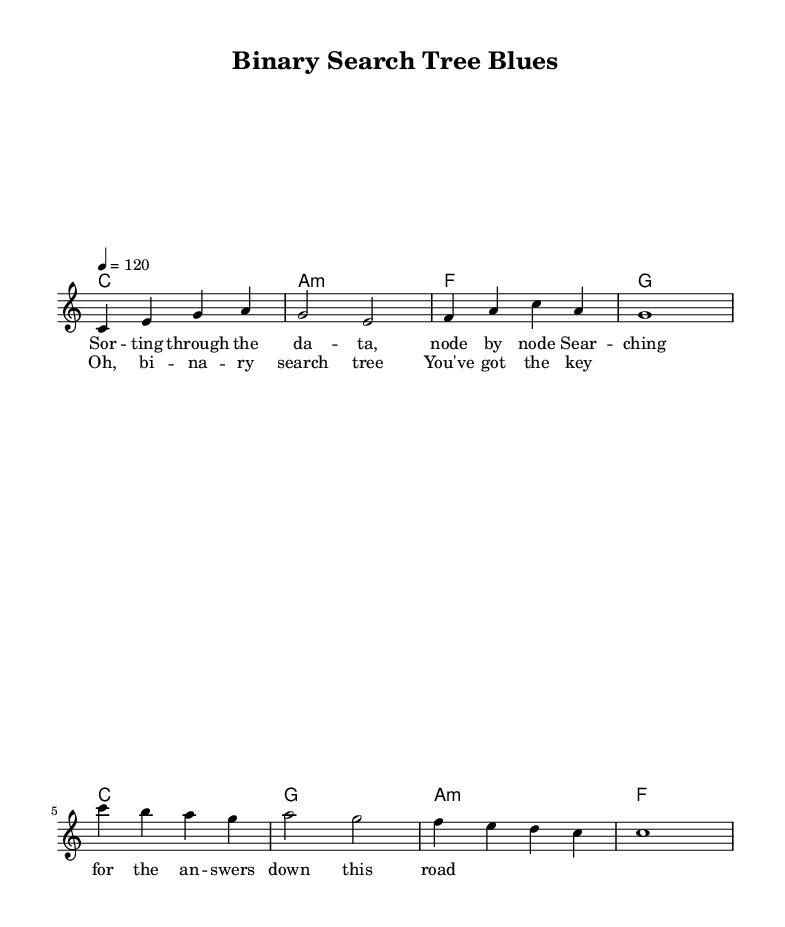What is the title of the song? The title is explicitly stated in the header as "Binary Search Tree Blues".
Answer: Binary Search Tree Blues What is the key signature of this music? The key is indicated as C major, which has no sharps or flats, shown in the global settings at the start.
Answer: C major What is the time signature of this music? The time signature is presented in the global settings as 4/4, indicating four beats per measure.
Answer: 4/4 What is the tempo marking for this music? The tempo is indicated as 4 = 120, meaning there are 120 quarter note beats per minute, also found in the global settings.
Answer: 120 How many measures are in the verse? The verse consists of four measures, as counted from the melody notation where the verse notes are placed.
Answer: 4 What type of song is "Binary Search Tree Blues"? The song falls under the genre of Indie pop, as indicated by the context of lyrics which reflect themes of algorithms and data structures, typical for this style.
Answer: Indie pop How many chords are used in the chorus? There are four unique chords listed in the harmony section for the chorus, corresponding to the melody notes during that section.
Answer: 4 